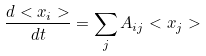Convert formula to latex. <formula><loc_0><loc_0><loc_500><loc_500>\frac { d < x _ { i } > } { d t } = \sum _ { j } A _ { i j } < x _ { j } ></formula> 